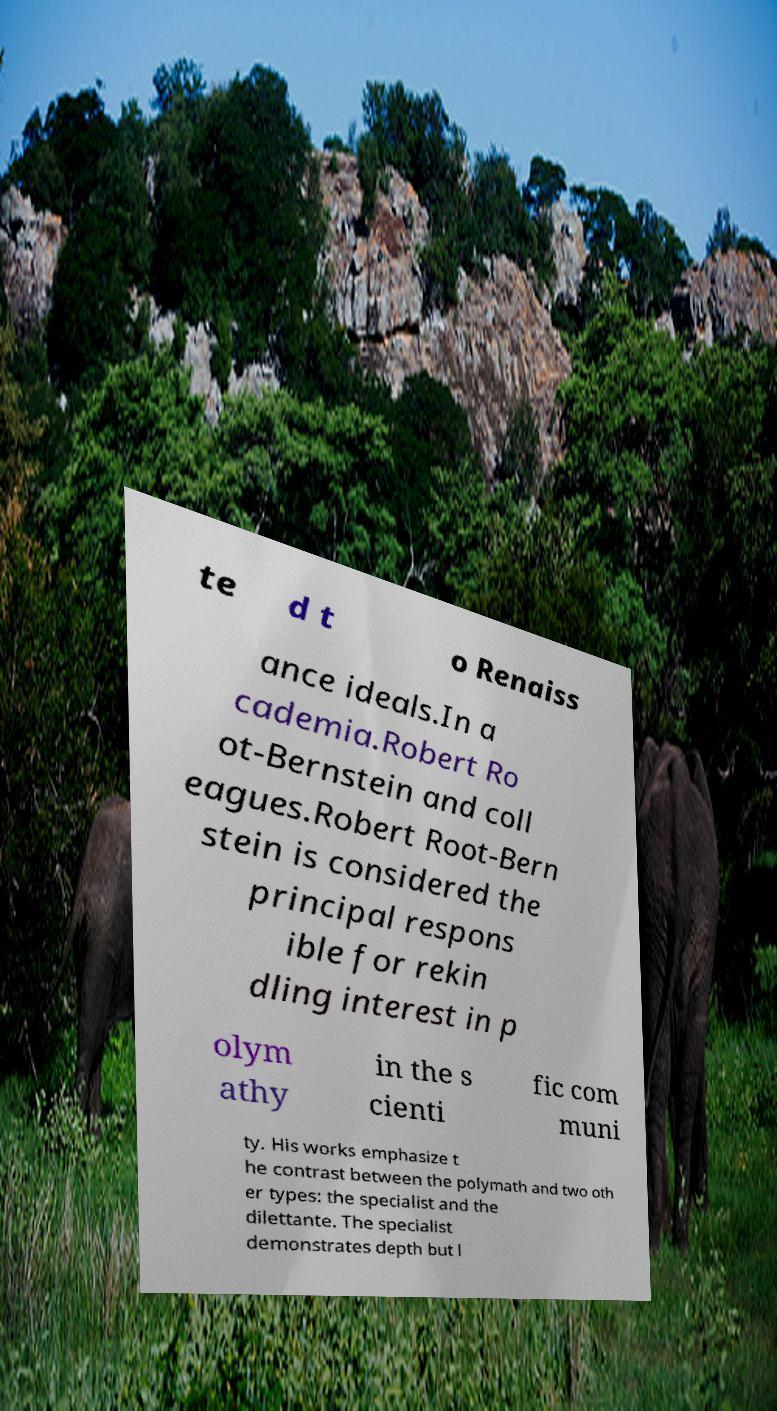Please identify and transcribe the text found in this image. te d t o Renaiss ance ideals.In a cademia.Robert Ro ot-Bernstein and coll eagues.Robert Root-Bern stein is considered the principal respons ible for rekin dling interest in p olym athy in the s cienti fic com muni ty. His works emphasize t he contrast between the polymath and two oth er types: the specialist and the dilettante. The specialist demonstrates depth but l 